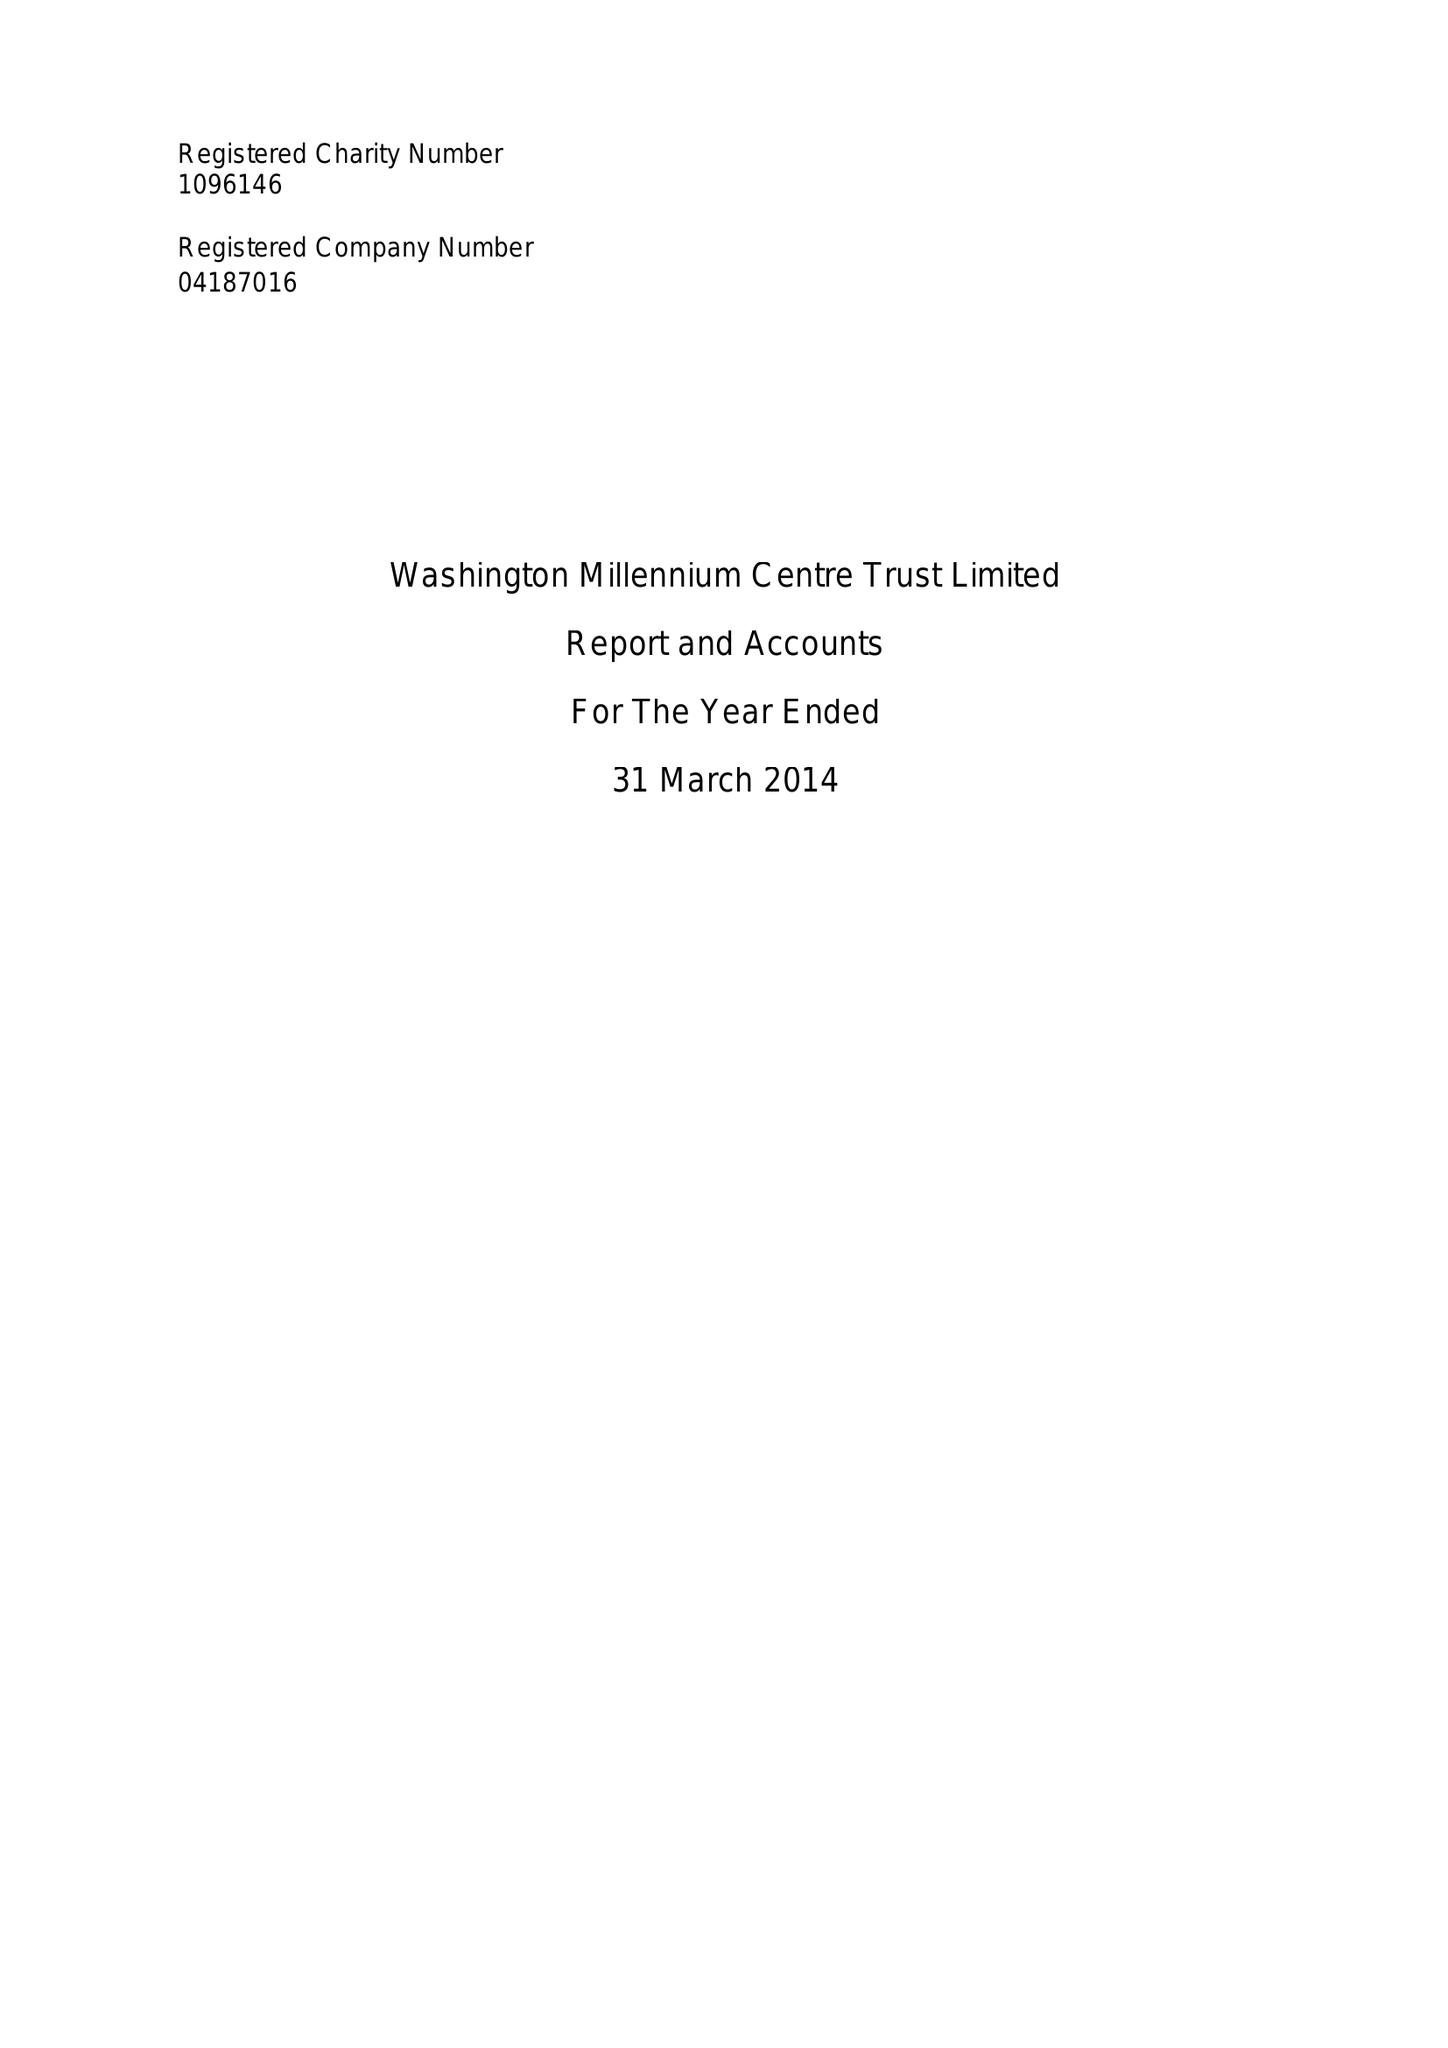What is the value for the address__street_line?
Answer the question using a single word or phrase. THE OVAL 